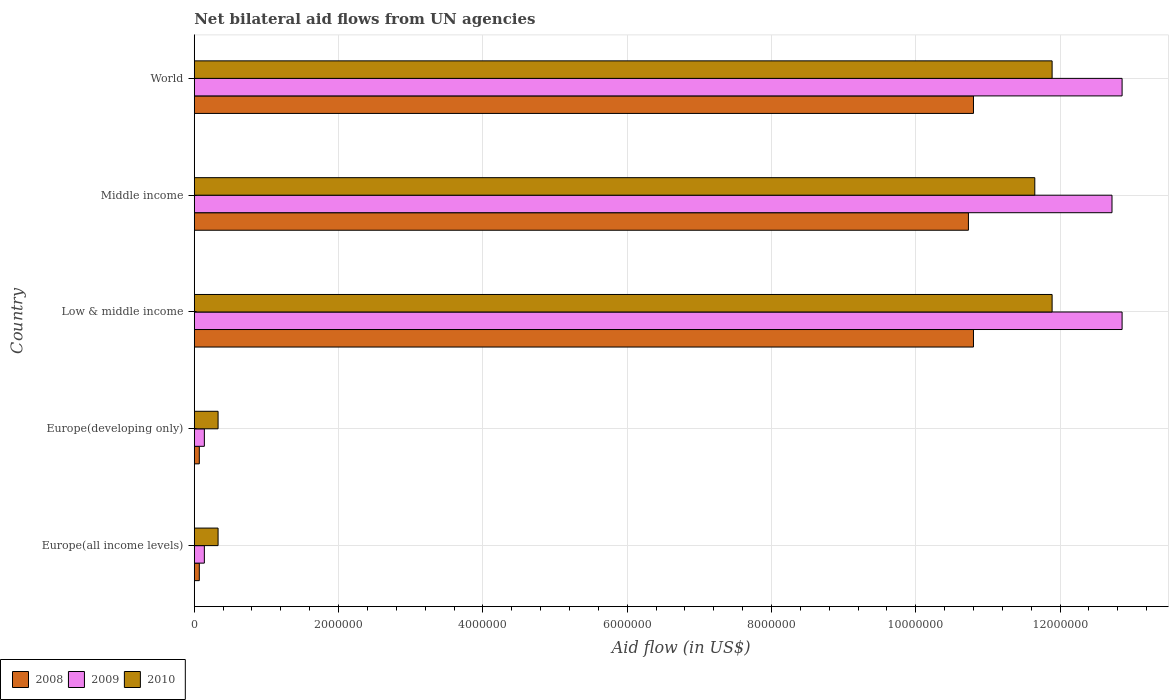Are the number of bars on each tick of the Y-axis equal?
Keep it short and to the point. Yes. How many bars are there on the 2nd tick from the bottom?
Offer a terse response. 3. What is the label of the 4th group of bars from the top?
Make the answer very short. Europe(developing only). What is the net bilateral aid flow in 2008 in Middle income?
Provide a succinct answer. 1.07e+07. Across all countries, what is the maximum net bilateral aid flow in 2009?
Offer a terse response. 1.29e+07. Across all countries, what is the minimum net bilateral aid flow in 2010?
Offer a terse response. 3.30e+05. In which country was the net bilateral aid flow in 2009 maximum?
Ensure brevity in your answer.  Low & middle income. In which country was the net bilateral aid flow in 2010 minimum?
Your answer should be very brief. Europe(all income levels). What is the total net bilateral aid flow in 2010 in the graph?
Make the answer very short. 3.61e+07. What is the difference between the net bilateral aid flow in 2010 in Europe(developing only) and that in Low & middle income?
Ensure brevity in your answer.  -1.16e+07. What is the difference between the net bilateral aid flow in 2008 in Middle income and the net bilateral aid flow in 2009 in Europe(all income levels)?
Make the answer very short. 1.06e+07. What is the average net bilateral aid flow in 2009 per country?
Offer a very short reply. 7.74e+06. What is the difference between the net bilateral aid flow in 2009 and net bilateral aid flow in 2008 in Middle income?
Your answer should be compact. 1.99e+06. In how many countries, is the net bilateral aid flow in 2008 greater than 12800000 US$?
Give a very brief answer. 0. What is the ratio of the net bilateral aid flow in 2010 in Europe(all income levels) to that in Low & middle income?
Your answer should be very brief. 0.03. Is the net bilateral aid flow in 2008 in Low & middle income less than that in World?
Give a very brief answer. No. What is the difference between the highest and the lowest net bilateral aid flow in 2010?
Make the answer very short. 1.16e+07. What does the 3rd bar from the top in Europe(all income levels) represents?
Your answer should be very brief. 2008. What does the 2nd bar from the bottom in Low & middle income represents?
Your answer should be very brief. 2009. Is it the case that in every country, the sum of the net bilateral aid flow in 2010 and net bilateral aid flow in 2008 is greater than the net bilateral aid flow in 2009?
Your answer should be compact. Yes. How many bars are there?
Your answer should be compact. 15. Are the values on the major ticks of X-axis written in scientific E-notation?
Your response must be concise. No. Does the graph contain grids?
Offer a terse response. Yes. What is the title of the graph?
Give a very brief answer. Net bilateral aid flows from UN agencies. Does "2001" appear as one of the legend labels in the graph?
Provide a succinct answer. No. What is the label or title of the X-axis?
Offer a terse response. Aid flow (in US$). What is the label or title of the Y-axis?
Keep it short and to the point. Country. What is the Aid flow (in US$) of 2009 in Europe(all income levels)?
Keep it short and to the point. 1.40e+05. What is the Aid flow (in US$) of 2010 in Europe(all income levels)?
Give a very brief answer. 3.30e+05. What is the Aid flow (in US$) of 2009 in Europe(developing only)?
Offer a very short reply. 1.40e+05. What is the Aid flow (in US$) in 2010 in Europe(developing only)?
Ensure brevity in your answer.  3.30e+05. What is the Aid flow (in US$) of 2008 in Low & middle income?
Give a very brief answer. 1.08e+07. What is the Aid flow (in US$) in 2009 in Low & middle income?
Provide a short and direct response. 1.29e+07. What is the Aid flow (in US$) in 2010 in Low & middle income?
Offer a terse response. 1.19e+07. What is the Aid flow (in US$) of 2008 in Middle income?
Your answer should be compact. 1.07e+07. What is the Aid flow (in US$) of 2009 in Middle income?
Provide a succinct answer. 1.27e+07. What is the Aid flow (in US$) in 2010 in Middle income?
Provide a short and direct response. 1.16e+07. What is the Aid flow (in US$) in 2008 in World?
Provide a succinct answer. 1.08e+07. What is the Aid flow (in US$) of 2009 in World?
Offer a very short reply. 1.29e+07. What is the Aid flow (in US$) in 2010 in World?
Offer a very short reply. 1.19e+07. Across all countries, what is the maximum Aid flow (in US$) of 2008?
Your response must be concise. 1.08e+07. Across all countries, what is the maximum Aid flow (in US$) in 2009?
Give a very brief answer. 1.29e+07. Across all countries, what is the maximum Aid flow (in US$) of 2010?
Your response must be concise. 1.19e+07. Across all countries, what is the minimum Aid flow (in US$) of 2008?
Ensure brevity in your answer.  7.00e+04. Across all countries, what is the minimum Aid flow (in US$) of 2009?
Make the answer very short. 1.40e+05. What is the total Aid flow (in US$) in 2008 in the graph?
Offer a terse response. 3.25e+07. What is the total Aid flow (in US$) of 2009 in the graph?
Offer a very short reply. 3.87e+07. What is the total Aid flow (in US$) in 2010 in the graph?
Keep it short and to the point. 3.61e+07. What is the difference between the Aid flow (in US$) in 2008 in Europe(all income levels) and that in Europe(developing only)?
Offer a very short reply. 0. What is the difference between the Aid flow (in US$) of 2010 in Europe(all income levels) and that in Europe(developing only)?
Offer a terse response. 0. What is the difference between the Aid flow (in US$) of 2008 in Europe(all income levels) and that in Low & middle income?
Keep it short and to the point. -1.07e+07. What is the difference between the Aid flow (in US$) in 2009 in Europe(all income levels) and that in Low & middle income?
Ensure brevity in your answer.  -1.27e+07. What is the difference between the Aid flow (in US$) of 2010 in Europe(all income levels) and that in Low & middle income?
Offer a terse response. -1.16e+07. What is the difference between the Aid flow (in US$) in 2008 in Europe(all income levels) and that in Middle income?
Your answer should be very brief. -1.07e+07. What is the difference between the Aid flow (in US$) in 2009 in Europe(all income levels) and that in Middle income?
Keep it short and to the point. -1.26e+07. What is the difference between the Aid flow (in US$) of 2010 in Europe(all income levels) and that in Middle income?
Provide a short and direct response. -1.13e+07. What is the difference between the Aid flow (in US$) in 2008 in Europe(all income levels) and that in World?
Ensure brevity in your answer.  -1.07e+07. What is the difference between the Aid flow (in US$) in 2009 in Europe(all income levels) and that in World?
Make the answer very short. -1.27e+07. What is the difference between the Aid flow (in US$) in 2010 in Europe(all income levels) and that in World?
Your answer should be compact. -1.16e+07. What is the difference between the Aid flow (in US$) in 2008 in Europe(developing only) and that in Low & middle income?
Give a very brief answer. -1.07e+07. What is the difference between the Aid flow (in US$) of 2009 in Europe(developing only) and that in Low & middle income?
Your answer should be compact. -1.27e+07. What is the difference between the Aid flow (in US$) of 2010 in Europe(developing only) and that in Low & middle income?
Provide a succinct answer. -1.16e+07. What is the difference between the Aid flow (in US$) of 2008 in Europe(developing only) and that in Middle income?
Make the answer very short. -1.07e+07. What is the difference between the Aid flow (in US$) of 2009 in Europe(developing only) and that in Middle income?
Ensure brevity in your answer.  -1.26e+07. What is the difference between the Aid flow (in US$) of 2010 in Europe(developing only) and that in Middle income?
Your answer should be compact. -1.13e+07. What is the difference between the Aid flow (in US$) in 2008 in Europe(developing only) and that in World?
Provide a succinct answer. -1.07e+07. What is the difference between the Aid flow (in US$) in 2009 in Europe(developing only) and that in World?
Provide a short and direct response. -1.27e+07. What is the difference between the Aid flow (in US$) of 2010 in Europe(developing only) and that in World?
Provide a succinct answer. -1.16e+07. What is the difference between the Aid flow (in US$) in 2008 in Low & middle income and that in Middle income?
Provide a succinct answer. 7.00e+04. What is the difference between the Aid flow (in US$) in 2009 in Low & middle income and that in Middle income?
Make the answer very short. 1.40e+05. What is the difference between the Aid flow (in US$) in 2008 in Low & middle income and that in World?
Ensure brevity in your answer.  0. What is the difference between the Aid flow (in US$) in 2009 in Low & middle income and that in World?
Your answer should be very brief. 0. What is the difference between the Aid flow (in US$) of 2010 in Low & middle income and that in World?
Provide a succinct answer. 0. What is the difference between the Aid flow (in US$) of 2009 in Middle income and that in World?
Offer a terse response. -1.40e+05. What is the difference between the Aid flow (in US$) of 2008 in Europe(all income levels) and the Aid flow (in US$) of 2009 in Low & middle income?
Your response must be concise. -1.28e+07. What is the difference between the Aid flow (in US$) in 2008 in Europe(all income levels) and the Aid flow (in US$) in 2010 in Low & middle income?
Offer a terse response. -1.18e+07. What is the difference between the Aid flow (in US$) of 2009 in Europe(all income levels) and the Aid flow (in US$) of 2010 in Low & middle income?
Offer a terse response. -1.18e+07. What is the difference between the Aid flow (in US$) of 2008 in Europe(all income levels) and the Aid flow (in US$) of 2009 in Middle income?
Provide a short and direct response. -1.26e+07. What is the difference between the Aid flow (in US$) in 2008 in Europe(all income levels) and the Aid flow (in US$) in 2010 in Middle income?
Provide a short and direct response. -1.16e+07. What is the difference between the Aid flow (in US$) of 2009 in Europe(all income levels) and the Aid flow (in US$) of 2010 in Middle income?
Offer a terse response. -1.15e+07. What is the difference between the Aid flow (in US$) of 2008 in Europe(all income levels) and the Aid flow (in US$) of 2009 in World?
Make the answer very short. -1.28e+07. What is the difference between the Aid flow (in US$) of 2008 in Europe(all income levels) and the Aid flow (in US$) of 2010 in World?
Provide a succinct answer. -1.18e+07. What is the difference between the Aid flow (in US$) of 2009 in Europe(all income levels) and the Aid flow (in US$) of 2010 in World?
Make the answer very short. -1.18e+07. What is the difference between the Aid flow (in US$) of 2008 in Europe(developing only) and the Aid flow (in US$) of 2009 in Low & middle income?
Your answer should be very brief. -1.28e+07. What is the difference between the Aid flow (in US$) of 2008 in Europe(developing only) and the Aid flow (in US$) of 2010 in Low & middle income?
Give a very brief answer. -1.18e+07. What is the difference between the Aid flow (in US$) of 2009 in Europe(developing only) and the Aid flow (in US$) of 2010 in Low & middle income?
Keep it short and to the point. -1.18e+07. What is the difference between the Aid flow (in US$) of 2008 in Europe(developing only) and the Aid flow (in US$) of 2009 in Middle income?
Keep it short and to the point. -1.26e+07. What is the difference between the Aid flow (in US$) of 2008 in Europe(developing only) and the Aid flow (in US$) of 2010 in Middle income?
Your answer should be very brief. -1.16e+07. What is the difference between the Aid flow (in US$) in 2009 in Europe(developing only) and the Aid flow (in US$) in 2010 in Middle income?
Your answer should be compact. -1.15e+07. What is the difference between the Aid flow (in US$) of 2008 in Europe(developing only) and the Aid flow (in US$) of 2009 in World?
Offer a very short reply. -1.28e+07. What is the difference between the Aid flow (in US$) of 2008 in Europe(developing only) and the Aid flow (in US$) of 2010 in World?
Provide a succinct answer. -1.18e+07. What is the difference between the Aid flow (in US$) in 2009 in Europe(developing only) and the Aid flow (in US$) in 2010 in World?
Your answer should be compact. -1.18e+07. What is the difference between the Aid flow (in US$) of 2008 in Low & middle income and the Aid flow (in US$) of 2009 in Middle income?
Give a very brief answer. -1.92e+06. What is the difference between the Aid flow (in US$) of 2008 in Low & middle income and the Aid flow (in US$) of 2010 in Middle income?
Ensure brevity in your answer.  -8.50e+05. What is the difference between the Aid flow (in US$) of 2009 in Low & middle income and the Aid flow (in US$) of 2010 in Middle income?
Provide a succinct answer. 1.21e+06. What is the difference between the Aid flow (in US$) of 2008 in Low & middle income and the Aid flow (in US$) of 2009 in World?
Make the answer very short. -2.06e+06. What is the difference between the Aid flow (in US$) in 2008 in Low & middle income and the Aid flow (in US$) in 2010 in World?
Provide a short and direct response. -1.09e+06. What is the difference between the Aid flow (in US$) in 2009 in Low & middle income and the Aid flow (in US$) in 2010 in World?
Offer a very short reply. 9.70e+05. What is the difference between the Aid flow (in US$) of 2008 in Middle income and the Aid flow (in US$) of 2009 in World?
Your response must be concise. -2.13e+06. What is the difference between the Aid flow (in US$) in 2008 in Middle income and the Aid flow (in US$) in 2010 in World?
Give a very brief answer. -1.16e+06. What is the difference between the Aid flow (in US$) of 2009 in Middle income and the Aid flow (in US$) of 2010 in World?
Your answer should be compact. 8.30e+05. What is the average Aid flow (in US$) in 2008 per country?
Ensure brevity in your answer.  6.49e+06. What is the average Aid flow (in US$) of 2009 per country?
Provide a short and direct response. 7.74e+06. What is the average Aid flow (in US$) of 2010 per country?
Make the answer very short. 7.22e+06. What is the difference between the Aid flow (in US$) of 2008 and Aid flow (in US$) of 2009 in Europe(all income levels)?
Offer a terse response. -7.00e+04. What is the difference between the Aid flow (in US$) of 2008 and Aid flow (in US$) of 2010 in Europe(all income levels)?
Offer a terse response. -2.60e+05. What is the difference between the Aid flow (in US$) in 2008 and Aid flow (in US$) in 2009 in Europe(developing only)?
Provide a short and direct response. -7.00e+04. What is the difference between the Aid flow (in US$) in 2008 and Aid flow (in US$) in 2010 in Europe(developing only)?
Make the answer very short. -2.60e+05. What is the difference between the Aid flow (in US$) in 2008 and Aid flow (in US$) in 2009 in Low & middle income?
Give a very brief answer. -2.06e+06. What is the difference between the Aid flow (in US$) of 2008 and Aid flow (in US$) of 2010 in Low & middle income?
Your response must be concise. -1.09e+06. What is the difference between the Aid flow (in US$) of 2009 and Aid flow (in US$) of 2010 in Low & middle income?
Keep it short and to the point. 9.70e+05. What is the difference between the Aid flow (in US$) of 2008 and Aid flow (in US$) of 2009 in Middle income?
Offer a very short reply. -1.99e+06. What is the difference between the Aid flow (in US$) in 2008 and Aid flow (in US$) in 2010 in Middle income?
Your response must be concise. -9.20e+05. What is the difference between the Aid flow (in US$) of 2009 and Aid flow (in US$) of 2010 in Middle income?
Give a very brief answer. 1.07e+06. What is the difference between the Aid flow (in US$) of 2008 and Aid flow (in US$) of 2009 in World?
Your answer should be compact. -2.06e+06. What is the difference between the Aid flow (in US$) of 2008 and Aid flow (in US$) of 2010 in World?
Provide a short and direct response. -1.09e+06. What is the difference between the Aid flow (in US$) of 2009 and Aid flow (in US$) of 2010 in World?
Provide a short and direct response. 9.70e+05. What is the ratio of the Aid flow (in US$) in 2008 in Europe(all income levels) to that in Europe(developing only)?
Your answer should be compact. 1. What is the ratio of the Aid flow (in US$) of 2008 in Europe(all income levels) to that in Low & middle income?
Offer a terse response. 0.01. What is the ratio of the Aid flow (in US$) in 2009 in Europe(all income levels) to that in Low & middle income?
Provide a short and direct response. 0.01. What is the ratio of the Aid flow (in US$) in 2010 in Europe(all income levels) to that in Low & middle income?
Offer a terse response. 0.03. What is the ratio of the Aid flow (in US$) in 2008 in Europe(all income levels) to that in Middle income?
Your answer should be compact. 0.01. What is the ratio of the Aid flow (in US$) of 2009 in Europe(all income levels) to that in Middle income?
Provide a succinct answer. 0.01. What is the ratio of the Aid flow (in US$) of 2010 in Europe(all income levels) to that in Middle income?
Provide a succinct answer. 0.03. What is the ratio of the Aid flow (in US$) in 2008 in Europe(all income levels) to that in World?
Your answer should be very brief. 0.01. What is the ratio of the Aid flow (in US$) of 2009 in Europe(all income levels) to that in World?
Make the answer very short. 0.01. What is the ratio of the Aid flow (in US$) in 2010 in Europe(all income levels) to that in World?
Provide a short and direct response. 0.03. What is the ratio of the Aid flow (in US$) in 2008 in Europe(developing only) to that in Low & middle income?
Provide a short and direct response. 0.01. What is the ratio of the Aid flow (in US$) in 2009 in Europe(developing only) to that in Low & middle income?
Provide a short and direct response. 0.01. What is the ratio of the Aid flow (in US$) of 2010 in Europe(developing only) to that in Low & middle income?
Provide a succinct answer. 0.03. What is the ratio of the Aid flow (in US$) in 2008 in Europe(developing only) to that in Middle income?
Provide a succinct answer. 0.01. What is the ratio of the Aid flow (in US$) of 2009 in Europe(developing only) to that in Middle income?
Your answer should be compact. 0.01. What is the ratio of the Aid flow (in US$) in 2010 in Europe(developing only) to that in Middle income?
Your answer should be very brief. 0.03. What is the ratio of the Aid flow (in US$) of 2008 in Europe(developing only) to that in World?
Provide a succinct answer. 0.01. What is the ratio of the Aid flow (in US$) of 2009 in Europe(developing only) to that in World?
Provide a short and direct response. 0.01. What is the ratio of the Aid flow (in US$) in 2010 in Europe(developing only) to that in World?
Make the answer very short. 0.03. What is the ratio of the Aid flow (in US$) of 2008 in Low & middle income to that in Middle income?
Your response must be concise. 1.01. What is the ratio of the Aid flow (in US$) in 2010 in Low & middle income to that in Middle income?
Provide a short and direct response. 1.02. What is the ratio of the Aid flow (in US$) of 2009 in Low & middle income to that in World?
Provide a short and direct response. 1. What is the ratio of the Aid flow (in US$) in 2010 in Low & middle income to that in World?
Ensure brevity in your answer.  1. What is the ratio of the Aid flow (in US$) of 2009 in Middle income to that in World?
Offer a very short reply. 0.99. What is the ratio of the Aid flow (in US$) in 2010 in Middle income to that in World?
Keep it short and to the point. 0.98. What is the difference between the highest and the second highest Aid flow (in US$) of 2008?
Provide a short and direct response. 0. What is the difference between the highest and the second highest Aid flow (in US$) in 2009?
Offer a terse response. 0. What is the difference between the highest and the lowest Aid flow (in US$) in 2008?
Your response must be concise. 1.07e+07. What is the difference between the highest and the lowest Aid flow (in US$) in 2009?
Ensure brevity in your answer.  1.27e+07. What is the difference between the highest and the lowest Aid flow (in US$) of 2010?
Offer a very short reply. 1.16e+07. 